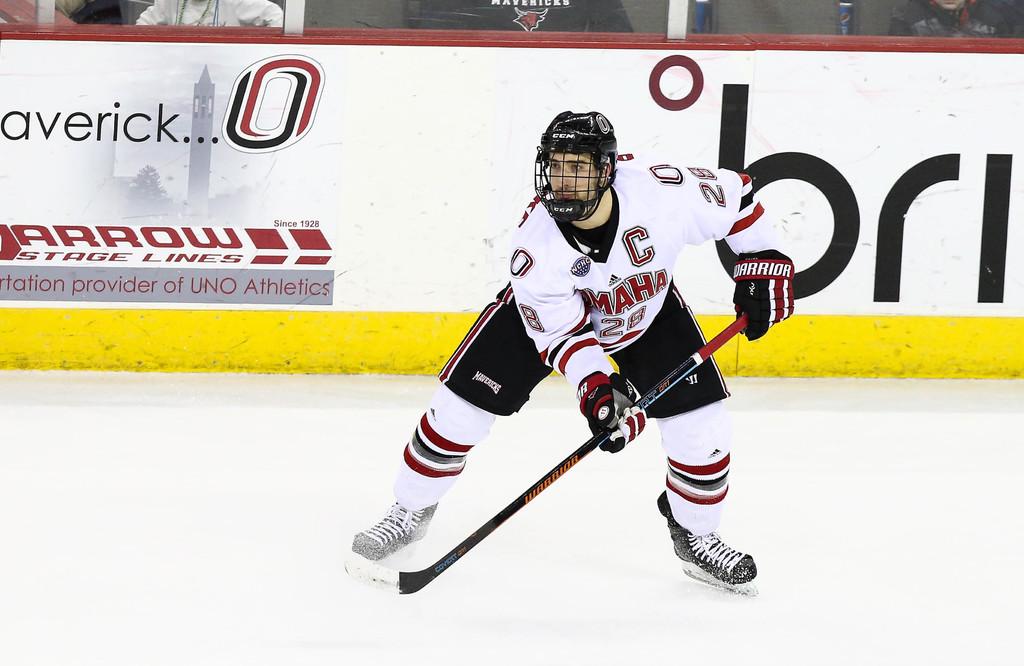What is the hockey team name?
Provide a short and direct response. Omaha. What is advertised on back wall?
Provide a succinct answer. Arrow stage lines. 